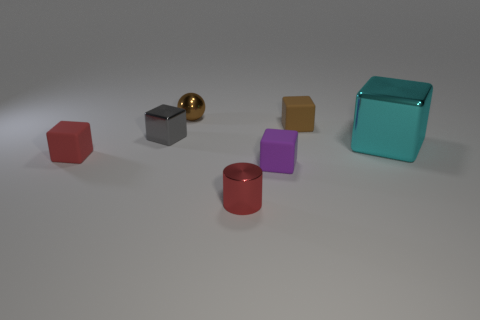Is there any other thing that has the same size as the cyan cube?
Make the answer very short. No. Are there fewer tiny red objects to the right of the large thing than red objects behind the small red metal cylinder?
Your answer should be very brief. Yes. What is the shape of the tiny shiny thing that is right of the tiny gray thing and behind the tiny red shiny thing?
Offer a very short reply. Sphere. What number of big cyan shiny objects are the same shape as the small purple matte thing?
Make the answer very short. 1. The brown object that is made of the same material as the purple object is what size?
Offer a terse response. Small. Is the number of blue rubber things greater than the number of large metallic blocks?
Provide a short and direct response. No. There is a metallic block to the left of the cyan block; what color is it?
Ensure brevity in your answer.  Gray. There is a metallic thing that is both to the left of the tiny red metal thing and in front of the tiny brown ball; what is its size?
Provide a short and direct response. Small. What number of other cubes have the same size as the gray block?
Your response must be concise. 3. There is a cyan object that is the same shape as the brown matte thing; what material is it?
Give a very brief answer. Metal. 